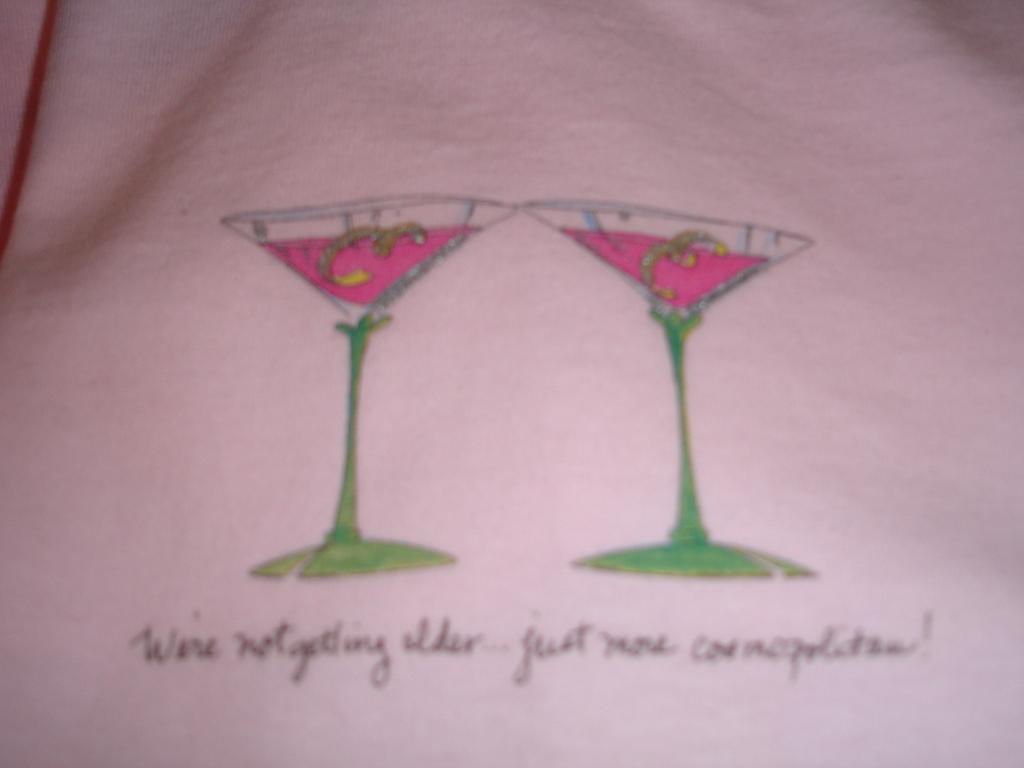How would you summarize this image in a sentence or two? In this picture we can see a paper, we can see drawing of two glasses of drinks, at the bottom there is some handwritten text. 